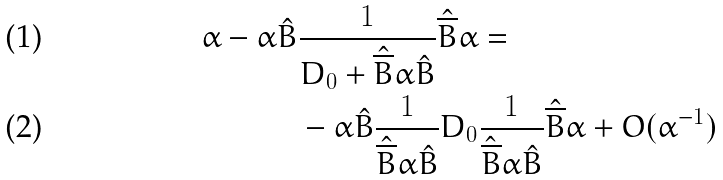<formula> <loc_0><loc_0><loc_500><loc_500>\alpha - \alpha \hat { B } & \frac { 1 } { D _ { 0 } + \hat { \overline { B } } \alpha \hat { B } } \hat { \overline { B } } \alpha = \\ & - \alpha \hat { B } \frac { 1 } { \hat { \overline { B } } \alpha \hat { B } } D _ { 0 } \frac { 1 } { \hat { \overline { B } } \alpha \hat { B } } \hat { \overline { B } } \alpha + O ( \alpha ^ { - 1 } )</formula> 